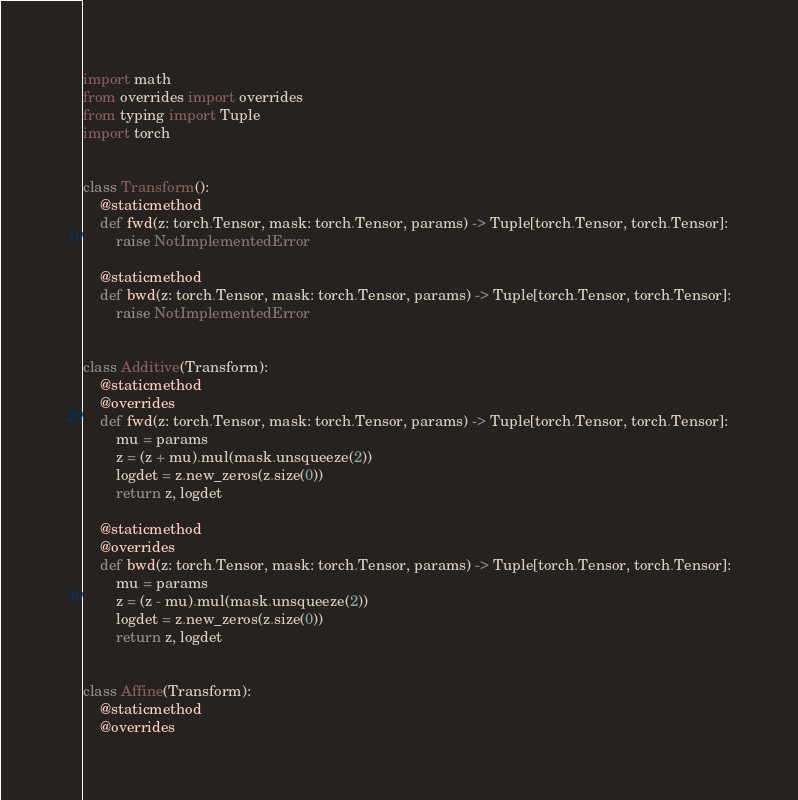<code> <loc_0><loc_0><loc_500><loc_500><_Python_>import math
from overrides import overrides
from typing import Tuple
import torch


class Transform():
    @staticmethod
    def fwd(z: torch.Tensor, mask: torch.Tensor, params) -> Tuple[torch.Tensor, torch.Tensor]:
        raise NotImplementedError

    @staticmethod
    def bwd(z: torch.Tensor, mask: torch.Tensor, params) -> Tuple[torch.Tensor, torch.Tensor]:
        raise NotImplementedError


class Additive(Transform):
    @staticmethod
    @overrides
    def fwd(z: torch.Tensor, mask: torch.Tensor, params) -> Tuple[torch.Tensor, torch.Tensor]:
        mu = params
        z = (z + mu).mul(mask.unsqueeze(2))
        logdet = z.new_zeros(z.size(0))
        return z, logdet

    @staticmethod
    @overrides
    def bwd(z: torch.Tensor, mask: torch.Tensor, params) -> Tuple[torch.Tensor, torch.Tensor]:
        mu = params
        z = (z - mu).mul(mask.unsqueeze(2))
        logdet = z.new_zeros(z.size(0))
        return z, logdet


class Affine(Transform):
    @staticmethod
    @overrides</code> 